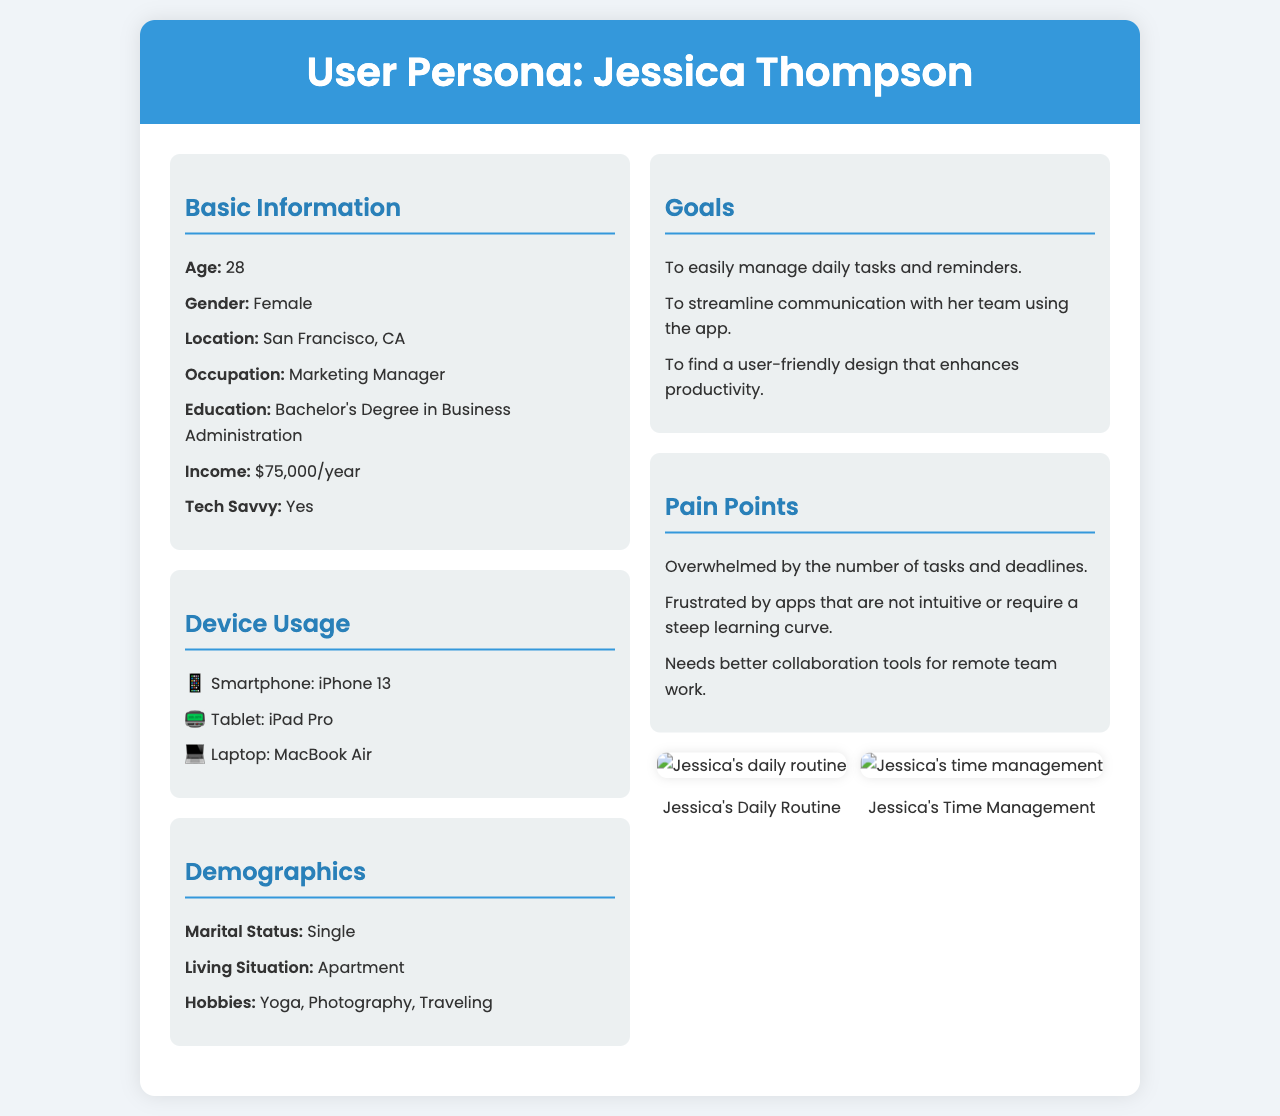What is Jessica's age? Jessica's age is explicitly mentioned in the basic information section.
Answer: 28 What is Jessica's occupation? The document provides Jessica's job title in the basic information section.
Answer: Marketing Manager What device does Jessica use as a tablet? The document lists the devices Jessica uses, including her tablet.
Answer: iPad Pro What are Jessica's main goals with the app? The document outlines Jessica's goals in a specific section.
Answer: Manage daily tasks How much is Jessica's annual income? The income figure is directly stated in the basic information section.
Answer: $75,000/year What is one of Jessica's pain points? The document specifies multiple pain points that relate to Jessica's experience with apps.
Answer: Overwhelmed What type of living situation does Jessica have? Jessica's living situation is mentioned in the demographics section of the document.
Answer: Apartment What hobbies does Jessica enjoy? The document provides details on Jessica's interests in the demographics section.
Answer: Yoga, Photography, Traveling What is highlighted in the visuals section? The visuals section features two images representing Jessica's daily schedule and time management.
Answer: Daily Routine and Time Management Chart 